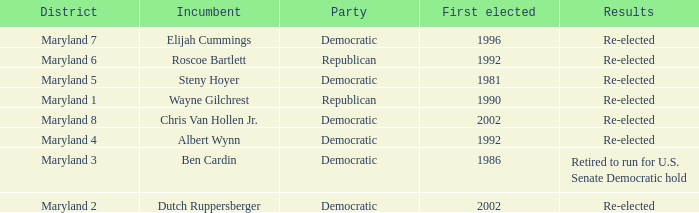Who is the incumbent who was first elected before 2002 from the maryland 3 district? Ben Cardin. 